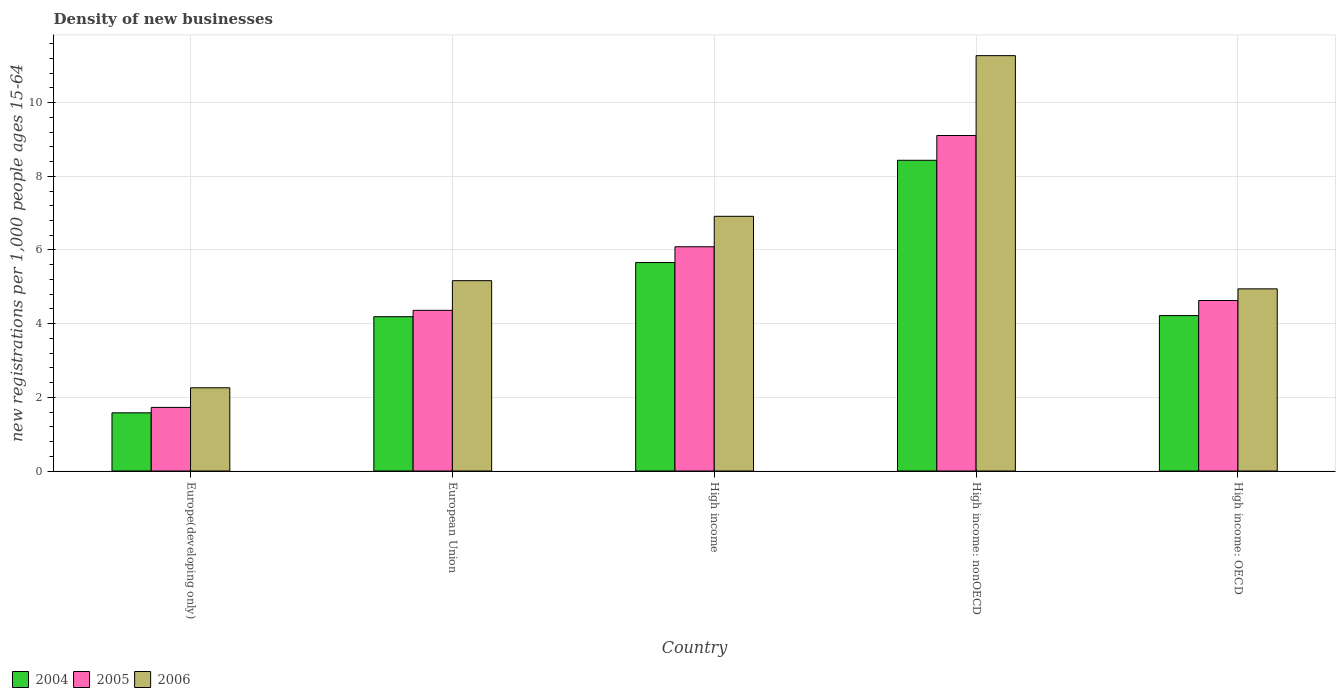How many groups of bars are there?
Ensure brevity in your answer.  5. Are the number of bars on each tick of the X-axis equal?
Give a very brief answer. Yes. What is the label of the 1st group of bars from the left?
Your answer should be very brief. Europe(developing only). What is the number of new registrations in 2004 in High income: nonOECD?
Give a very brief answer. 8.44. Across all countries, what is the maximum number of new registrations in 2004?
Keep it short and to the point. 8.44. Across all countries, what is the minimum number of new registrations in 2004?
Provide a short and direct response. 1.58. In which country was the number of new registrations in 2005 maximum?
Offer a terse response. High income: nonOECD. In which country was the number of new registrations in 2006 minimum?
Provide a short and direct response. Europe(developing only). What is the total number of new registrations in 2006 in the graph?
Give a very brief answer. 30.56. What is the difference between the number of new registrations in 2006 in European Union and that in High income: OECD?
Provide a succinct answer. 0.22. What is the difference between the number of new registrations in 2004 in Europe(developing only) and the number of new registrations in 2006 in High income?
Your response must be concise. -5.33. What is the average number of new registrations in 2006 per country?
Your response must be concise. 6.11. What is the difference between the number of new registrations of/in 2006 and number of new registrations of/in 2005 in High income: OECD?
Your response must be concise. 0.32. What is the ratio of the number of new registrations in 2006 in Europe(developing only) to that in High income?
Provide a short and direct response. 0.33. What is the difference between the highest and the second highest number of new registrations in 2005?
Make the answer very short. 4.48. What is the difference between the highest and the lowest number of new registrations in 2005?
Offer a very short reply. 7.38. In how many countries, is the number of new registrations in 2006 greater than the average number of new registrations in 2006 taken over all countries?
Ensure brevity in your answer.  2. What does the 3rd bar from the left in High income: OECD represents?
Make the answer very short. 2006. Are all the bars in the graph horizontal?
Give a very brief answer. No. How many countries are there in the graph?
Offer a very short reply. 5. Where does the legend appear in the graph?
Give a very brief answer. Bottom left. How many legend labels are there?
Make the answer very short. 3. How are the legend labels stacked?
Your answer should be compact. Horizontal. What is the title of the graph?
Your response must be concise. Density of new businesses. Does "2000" appear as one of the legend labels in the graph?
Give a very brief answer. No. What is the label or title of the Y-axis?
Offer a terse response. New registrations per 1,0 people ages 15-64. What is the new registrations per 1,000 people ages 15-64 of 2004 in Europe(developing only)?
Keep it short and to the point. 1.58. What is the new registrations per 1,000 people ages 15-64 in 2005 in Europe(developing only)?
Provide a short and direct response. 1.73. What is the new registrations per 1,000 people ages 15-64 in 2006 in Europe(developing only)?
Your response must be concise. 2.26. What is the new registrations per 1,000 people ages 15-64 of 2004 in European Union?
Offer a very short reply. 4.19. What is the new registrations per 1,000 people ages 15-64 of 2005 in European Union?
Offer a very short reply. 4.36. What is the new registrations per 1,000 people ages 15-64 of 2006 in European Union?
Offer a very short reply. 5.17. What is the new registrations per 1,000 people ages 15-64 in 2004 in High income?
Make the answer very short. 5.66. What is the new registrations per 1,000 people ages 15-64 in 2005 in High income?
Your response must be concise. 6.09. What is the new registrations per 1,000 people ages 15-64 of 2006 in High income?
Your answer should be compact. 6.91. What is the new registrations per 1,000 people ages 15-64 in 2004 in High income: nonOECD?
Offer a terse response. 8.44. What is the new registrations per 1,000 people ages 15-64 in 2005 in High income: nonOECD?
Keep it short and to the point. 9.11. What is the new registrations per 1,000 people ages 15-64 in 2006 in High income: nonOECD?
Make the answer very short. 11.28. What is the new registrations per 1,000 people ages 15-64 in 2004 in High income: OECD?
Your response must be concise. 4.22. What is the new registrations per 1,000 people ages 15-64 of 2005 in High income: OECD?
Offer a very short reply. 4.63. What is the new registrations per 1,000 people ages 15-64 of 2006 in High income: OECD?
Provide a succinct answer. 4.94. Across all countries, what is the maximum new registrations per 1,000 people ages 15-64 of 2004?
Keep it short and to the point. 8.44. Across all countries, what is the maximum new registrations per 1,000 people ages 15-64 of 2005?
Provide a short and direct response. 9.11. Across all countries, what is the maximum new registrations per 1,000 people ages 15-64 in 2006?
Provide a succinct answer. 11.28. Across all countries, what is the minimum new registrations per 1,000 people ages 15-64 of 2004?
Provide a succinct answer. 1.58. Across all countries, what is the minimum new registrations per 1,000 people ages 15-64 of 2005?
Make the answer very short. 1.73. Across all countries, what is the minimum new registrations per 1,000 people ages 15-64 in 2006?
Provide a short and direct response. 2.26. What is the total new registrations per 1,000 people ages 15-64 in 2004 in the graph?
Your answer should be compact. 24.08. What is the total new registrations per 1,000 people ages 15-64 of 2005 in the graph?
Your response must be concise. 25.91. What is the total new registrations per 1,000 people ages 15-64 in 2006 in the graph?
Offer a terse response. 30.56. What is the difference between the new registrations per 1,000 people ages 15-64 of 2004 in Europe(developing only) and that in European Union?
Your response must be concise. -2.61. What is the difference between the new registrations per 1,000 people ages 15-64 in 2005 in Europe(developing only) and that in European Union?
Ensure brevity in your answer.  -2.64. What is the difference between the new registrations per 1,000 people ages 15-64 of 2006 in Europe(developing only) and that in European Union?
Make the answer very short. -2.91. What is the difference between the new registrations per 1,000 people ages 15-64 of 2004 in Europe(developing only) and that in High income?
Give a very brief answer. -4.08. What is the difference between the new registrations per 1,000 people ages 15-64 in 2005 in Europe(developing only) and that in High income?
Your response must be concise. -4.36. What is the difference between the new registrations per 1,000 people ages 15-64 in 2006 in Europe(developing only) and that in High income?
Make the answer very short. -4.66. What is the difference between the new registrations per 1,000 people ages 15-64 in 2004 in Europe(developing only) and that in High income: nonOECD?
Offer a terse response. -6.86. What is the difference between the new registrations per 1,000 people ages 15-64 of 2005 in Europe(developing only) and that in High income: nonOECD?
Offer a very short reply. -7.38. What is the difference between the new registrations per 1,000 people ages 15-64 in 2006 in Europe(developing only) and that in High income: nonOECD?
Your answer should be compact. -9.02. What is the difference between the new registrations per 1,000 people ages 15-64 in 2004 in Europe(developing only) and that in High income: OECD?
Give a very brief answer. -2.64. What is the difference between the new registrations per 1,000 people ages 15-64 in 2005 in Europe(developing only) and that in High income: OECD?
Your answer should be very brief. -2.9. What is the difference between the new registrations per 1,000 people ages 15-64 in 2006 in Europe(developing only) and that in High income: OECD?
Offer a very short reply. -2.69. What is the difference between the new registrations per 1,000 people ages 15-64 in 2004 in European Union and that in High income?
Keep it short and to the point. -1.47. What is the difference between the new registrations per 1,000 people ages 15-64 of 2005 in European Union and that in High income?
Ensure brevity in your answer.  -1.73. What is the difference between the new registrations per 1,000 people ages 15-64 in 2006 in European Union and that in High income?
Your answer should be very brief. -1.75. What is the difference between the new registrations per 1,000 people ages 15-64 of 2004 in European Union and that in High income: nonOECD?
Provide a short and direct response. -4.25. What is the difference between the new registrations per 1,000 people ages 15-64 in 2005 in European Union and that in High income: nonOECD?
Your response must be concise. -4.75. What is the difference between the new registrations per 1,000 people ages 15-64 of 2006 in European Union and that in High income: nonOECD?
Your response must be concise. -6.11. What is the difference between the new registrations per 1,000 people ages 15-64 in 2004 in European Union and that in High income: OECD?
Offer a terse response. -0.03. What is the difference between the new registrations per 1,000 people ages 15-64 of 2005 in European Union and that in High income: OECD?
Provide a short and direct response. -0.27. What is the difference between the new registrations per 1,000 people ages 15-64 of 2006 in European Union and that in High income: OECD?
Provide a succinct answer. 0.22. What is the difference between the new registrations per 1,000 people ages 15-64 in 2004 in High income and that in High income: nonOECD?
Your response must be concise. -2.78. What is the difference between the new registrations per 1,000 people ages 15-64 in 2005 in High income and that in High income: nonOECD?
Make the answer very short. -3.02. What is the difference between the new registrations per 1,000 people ages 15-64 in 2006 in High income and that in High income: nonOECD?
Your answer should be very brief. -4.36. What is the difference between the new registrations per 1,000 people ages 15-64 of 2004 in High income and that in High income: OECD?
Ensure brevity in your answer.  1.44. What is the difference between the new registrations per 1,000 people ages 15-64 in 2005 in High income and that in High income: OECD?
Your answer should be compact. 1.46. What is the difference between the new registrations per 1,000 people ages 15-64 in 2006 in High income and that in High income: OECD?
Make the answer very short. 1.97. What is the difference between the new registrations per 1,000 people ages 15-64 in 2004 in High income: nonOECD and that in High income: OECD?
Make the answer very short. 4.22. What is the difference between the new registrations per 1,000 people ages 15-64 in 2005 in High income: nonOECD and that in High income: OECD?
Ensure brevity in your answer.  4.48. What is the difference between the new registrations per 1,000 people ages 15-64 of 2006 in High income: nonOECD and that in High income: OECD?
Provide a succinct answer. 6.33. What is the difference between the new registrations per 1,000 people ages 15-64 in 2004 in Europe(developing only) and the new registrations per 1,000 people ages 15-64 in 2005 in European Union?
Provide a succinct answer. -2.78. What is the difference between the new registrations per 1,000 people ages 15-64 of 2004 in Europe(developing only) and the new registrations per 1,000 people ages 15-64 of 2006 in European Union?
Keep it short and to the point. -3.59. What is the difference between the new registrations per 1,000 people ages 15-64 in 2005 in Europe(developing only) and the new registrations per 1,000 people ages 15-64 in 2006 in European Union?
Your answer should be compact. -3.44. What is the difference between the new registrations per 1,000 people ages 15-64 in 2004 in Europe(developing only) and the new registrations per 1,000 people ages 15-64 in 2005 in High income?
Ensure brevity in your answer.  -4.51. What is the difference between the new registrations per 1,000 people ages 15-64 in 2004 in Europe(developing only) and the new registrations per 1,000 people ages 15-64 in 2006 in High income?
Offer a terse response. -5.33. What is the difference between the new registrations per 1,000 people ages 15-64 in 2005 in Europe(developing only) and the new registrations per 1,000 people ages 15-64 in 2006 in High income?
Your answer should be very brief. -5.19. What is the difference between the new registrations per 1,000 people ages 15-64 of 2004 in Europe(developing only) and the new registrations per 1,000 people ages 15-64 of 2005 in High income: nonOECD?
Your answer should be very brief. -7.53. What is the difference between the new registrations per 1,000 people ages 15-64 of 2004 in Europe(developing only) and the new registrations per 1,000 people ages 15-64 of 2006 in High income: nonOECD?
Provide a succinct answer. -9.7. What is the difference between the new registrations per 1,000 people ages 15-64 in 2005 in Europe(developing only) and the new registrations per 1,000 people ages 15-64 in 2006 in High income: nonOECD?
Offer a terse response. -9.55. What is the difference between the new registrations per 1,000 people ages 15-64 in 2004 in Europe(developing only) and the new registrations per 1,000 people ages 15-64 in 2005 in High income: OECD?
Give a very brief answer. -3.05. What is the difference between the new registrations per 1,000 people ages 15-64 in 2004 in Europe(developing only) and the new registrations per 1,000 people ages 15-64 in 2006 in High income: OECD?
Offer a terse response. -3.37. What is the difference between the new registrations per 1,000 people ages 15-64 in 2005 in Europe(developing only) and the new registrations per 1,000 people ages 15-64 in 2006 in High income: OECD?
Your answer should be compact. -3.22. What is the difference between the new registrations per 1,000 people ages 15-64 in 2004 in European Union and the new registrations per 1,000 people ages 15-64 in 2005 in High income?
Offer a very short reply. -1.9. What is the difference between the new registrations per 1,000 people ages 15-64 in 2004 in European Union and the new registrations per 1,000 people ages 15-64 in 2006 in High income?
Make the answer very short. -2.73. What is the difference between the new registrations per 1,000 people ages 15-64 in 2005 in European Union and the new registrations per 1,000 people ages 15-64 in 2006 in High income?
Offer a very short reply. -2.55. What is the difference between the new registrations per 1,000 people ages 15-64 of 2004 in European Union and the new registrations per 1,000 people ages 15-64 of 2005 in High income: nonOECD?
Your answer should be very brief. -4.92. What is the difference between the new registrations per 1,000 people ages 15-64 of 2004 in European Union and the new registrations per 1,000 people ages 15-64 of 2006 in High income: nonOECD?
Offer a terse response. -7.09. What is the difference between the new registrations per 1,000 people ages 15-64 in 2005 in European Union and the new registrations per 1,000 people ages 15-64 in 2006 in High income: nonOECD?
Give a very brief answer. -6.91. What is the difference between the new registrations per 1,000 people ages 15-64 in 2004 in European Union and the new registrations per 1,000 people ages 15-64 in 2005 in High income: OECD?
Your answer should be compact. -0.44. What is the difference between the new registrations per 1,000 people ages 15-64 in 2004 in European Union and the new registrations per 1,000 people ages 15-64 in 2006 in High income: OECD?
Provide a short and direct response. -0.76. What is the difference between the new registrations per 1,000 people ages 15-64 in 2005 in European Union and the new registrations per 1,000 people ages 15-64 in 2006 in High income: OECD?
Your answer should be very brief. -0.58. What is the difference between the new registrations per 1,000 people ages 15-64 of 2004 in High income and the new registrations per 1,000 people ages 15-64 of 2005 in High income: nonOECD?
Keep it short and to the point. -3.45. What is the difference between the new registrations per 1,000 people ages 15-64 in 2004 in High income and the new registrations per 1,000 people ages 15-64 in 2006 in High income: nonOECD?
Keep it short and to the point. -5.62. What is the difference between the new registrations per 1,000 people ages 15-64 in 2005 in High income and the new registrations per 1,000 people ages 15-64 in 2006 in High income: nonOECD?
Your answer should be very brief. -5.19. What is the difference between the new registrations per 1,000 people ages 15-64 of 2004 in High income and the new registrations per 1,000 people ages 15-64 of 2005 in High income: OECD?
Offer a terse response. 1.03. What is the difference between the new registrations per 1,000 people ages 15-64 in 2004 in High income and the new registrations per 1,000 people ages 15-64 in 2006 in High income: OECD?
Ensure brevity in your answer.  0.71. What is the difference between the new registrations per 1,000 people ages 15-64 in 2005 in High income and the new registrations per 1,000 people ages 15-64 in 2006 in High income: OECD?
Offer a terse response. 1.14. What is the difference between the new registrations per 1,000 people ages 15-64 in 2004 in High income: nonOECD and the new registrations per 1,000 people ages 15-64 in 2005 in High income: OECD?
Offer a terse response. 3.81. What is the difference between the new registrations per 1,000 people ages 15-64 of 2004 in High income: nonOECD and the new registrations per 1,000 people ages 15-64 of 2006 in High income: OECD?
Your response must be concise. 3.49. What is the difference between the new registrations per 1,000 people ages 15-64 in 2005 in High income: nonOECD and the new registrations per 1,000 people ages 15-64 in 2006 in High income: OECD?
Offer a very short reply. 4.16. What is the average new registrations per 1,000 people ages 15-64 in 2004 per country?
Provide a succinct answer. 4.82. What is the average new registrations per 1,000 people ages 15-64 in 2005 per country?
Make the answer very short. 5.18. What is the average new registrations per 1,000 people ages 15-64 of 2006 per country?
Give a very brief answer. 6.11. What is the difference between the new registrations per 1,000 people ages 15-64 in 2004 and new registrations per 1,000 people ages 15-64 in 2005 in Europe(developing only)?
Your answer should be compact. -0.15. What is the difference between the new registrations per 1,000 people ages 15-64 in 2004 and new registrations per 1,000 people ages 15-64 in 2006 in Europe(developing only)?
Give a very brief answer. -0.68. What is the difference between the new registrations per 1,000 people ages 15-64 in 2005 and new registrations per 1,000 people ages 15-64 in 2006 in Europe(developing only)?
Make the answer very short. -0.53. What is the difference between the new registrations per 1,000 people ages 15-64 of 2004 and new registrations per 1,000 people ages 15-64 of 2005 in European Union?
Keep it short and to the point. -0.17. What is the difference between the new registrations per 1,000 people ages 15-64 of 2004 and new registrations per 1,000 people ages 15-64 of 2006 in European Union?
Keep it short and to the point. -0.98. What is the difference between the new registrations per 1,000 people ages 15-64 in 2005 and new registrations per 1,000 people ages 15-64 in 2006 in European Union?
Keep it short and to the point. -0.81. What is the difference between the new registrations per 1,000 people ages 15-64 in 2004 and new registrations per 1,000 people ages 15-64 in 2005 in High income?
Make the answer very short. -0.43. What is the difference between the new registrations per 1,000 people ages 15-64 in 2004 and new registrations per 1,000 people ages 15-64 in 2006 in High income?
Offer a terse response. -1.26. What is the difference between the new registrations per 1,000 people ages 15-64 in 2005 and new registrations per 1,000 people ages 15-64 in 2006 in High income?
Your answer should be very brief. -0.83. What is the difference between the new registrations per 1,000 people ages 15-64 of 2004 and new registrations per 1,000 people ages 15-64 of 2005 in High income: nonOECD?
Provide a succinct answer. -0.67. What is the difference between the new registrations per 1,000 people ages 15-64 of 2004 and new registrations per 1,000 people ages 15-64 of 2006 in High income: nonOECD?
Keep it short and to the point. -2.84. What is the difference between the new registrations per 1,000 people ages 15-64 of 2005 and new registrations per 1,000 people ages 15-64 of 2006 in High income: nonOECD?
Provide a short and direct response. -2.17. What is the difference between the new registrations per 1,000 people ages 15-64 of 2004 and new registrations per 1,000 people ages 15-64 of 2005 in High income: OECD?
Provide a short and direct response. -0.41. What is the difference between the new registrations per 1,000 people ages 15-64 in 2004 and new registrations per 1,000 people ages 15-64 in 2006 in High income: OECD?
Your answer should be compact. -0.73. What is the difference between the new registrations per 1,000 people ages 15-64 of 2005 and new registrations per 1,000 people ages 15-64 of 2006 in High income: OECD?
Make the answer very short. -0.32. What is the ratio of the new registrations per 1,000 people ages 15-64 in 2004 in Europe(developing only) to that in European Union?
Ensure brevity in your answer.  0.38. What is the ratio of the new registrations per 1,000 people ages 15-64 in 2005 in Europe(developing only) to that in European Union?
Your answer should be compact. 0.4. What is the ratio of the new registrations per 1,000 people ages 15-64 of 2006 in Europe(developing only) to that in European Union?
Make the answer very short. 0.44. What is the ratio of the new registrations per 1,000 people ages 15-64 in 2004 in Europe(developing only) to that in High income?
Offer a terse response. 0.28. What is the ratio of the new registrations per 1,000 people ages 15-64 of 2005 in Europe(developing only) to that in High income?
Your response must be concise. 0.28. What is the ratio of the new registrations per 1,000 people ages 15-64 of 2006 in Europe(developing only) to that in High income?
Ensure brevity in your answer.  0.33. What is the ratio of the new registrations per 1,000 people ages 15-64 of 2004 in Europe(developing only) to that in High income: nonOECD?
Offer a very short reply. 0.19. What is the ratio of the new registrations per 1,000 people ages 15-64 in 2005 in Europe(developing only) to that in High income: nonOECD?
Offer a very short reply. 0.19. What is the ratio of the new registrations per 1,000 people ages 15-64 of 2006 in Europe(developing only) to that in High income: nonOECD?
Provide a succinct answer. 0.2. What is the ratio of the new registrations per 1,000 people ages 15-64 in 2004 in Europe(developing only) to that in High income: OECD?
Keep it short and to the point. 0.37. What is the ratio of the new registrations per 1,000 people ages 15-64 of 2005 in Europe(developing only) to that in High income: OECD?
Provide a short and direct response. 0.37. What is the ratio of the new registrations per 1,000 people ages 15-64 of 2006 in Europe(developing only) to that in High income: OECD?
Give a very brief answer. 0.46. What is the ratio of the new registrations per 1,000 people ages 15-64 in 2004 in European Union to that in High income?
Ensure brevity in your answer.  0.74. What is the ratio of the new registrations per 1,000 people ages 15-64 in 2005 in European Union to that in High income?
Provide a short and direct response. 0.72. What is the ratio of the new registrations per 1,000 people ages 15-64 of 2006 in European Union to that in High income?
Offer a very short reply. 0.75. What is the ratio of the new registrations per 1,000 people ages 15-64 in 2004 in European Union to that in High income: nonOECD?
Keep it short and to the point. 0.5. What is the ratio of the new registrations per 1,000 people ages 15-64 in 2005 in European Union to that in High income: nonOECD?
Your answer should be compact. 0.48. What is the ratio of the new registrations per 1,000 people ages 15-64 of 2006 in European Union to that in High income: nonOECD?
Your answer should be very brief. 0.46. What is the ratio of the new registrations per 1,000 people ages 15-64 in 2004 in European Union to that in High income: OECD?
Provide a succinct answer. 0.99. What is the ratio of the new registrations per 1,000 people ages 15-64 of 2005 in European Union to that in High income: OECD?
Make the answer very short. 0.94. What is the ratio of the new registrations per 1,000 people ages 15-64 of 2006 in European Union to that in High income: OECD?
Your answer should be compact. 1.04. What is the ratio of the new registrations per 1,000 people ages 15-64 of 2004 in High income to that in High income: nonOECD?
Your answer should be very brief. 0.67. What is the ratio of the new registrations per 1,000 people ages 15-64 in 2005 in High income to that in High income: nonOECD?
Ensure brevity in your answer.  0.67. What is the ratio of the new registrations per 1,000 people ages 15-64 in 2006 in High income to that in High income: nonOECD?
Offer a terse response. 0.61. What is the ratio of the new registrations per 1,000 people ages 15-64 of 2004 in High income to that in High income: OECD?
Provide a succinct answer. 1.34. What is the ratio of the new registrations per 1,000 people ages 15-64 of 2005 in High income to that in High income: OECD?
Give a very brief answer. 1.31. What is the ratio of the new registrations per 1,000 people ages 15-64 in 2006 in High income to that in High income: OECD?
Keep it short and to the point. 1.4. What is the ratio of the new registrations per 1,000 people ages 15-64 of 2004 in High income: nonOECD to that in High income: OECD?
Your answer should be compact. 2. What is the ratio of the new registrations per 1,000 people ages 15-64 of 2005 in High income: nonOECD to that in High income: OECD?
Provide a short and direct response. 1.97. What is the ratio of the new registrations per 1,000 people ages 15-64 of 2006 in High income: nonOECD to that in High income: OECD?
Your answer should be very brief. 2.28. What is the difference between the highest and the second highest new registrations per 1,000 people ages 15-64 in 2004?
Offer a very short reply. 2.78. What is the difference between the highest and the second highest new registrations per 1,000 people ages 15-64 of 2005?
Give a very brief answer. 3.02. What is the difference between the highest and the second highest new registrations per 1,000 people ages 15-64 in 2006?
Give a very brief answer. 4.36. What is the difference between the highest and the lowest new registrations per 1,000 people ages 15-64 of 2004?
Offer a terse response. 6.86. What is the difference between the highest and the lowest new registrations per 1,000 people ages 15-64 in 2005?
Give a very brief answer. 7.38. What is the difference between the highest and the lowest new registrations per 1,000 people ages 15-64 in 2006?
Your answer should be compact. 9.02. 